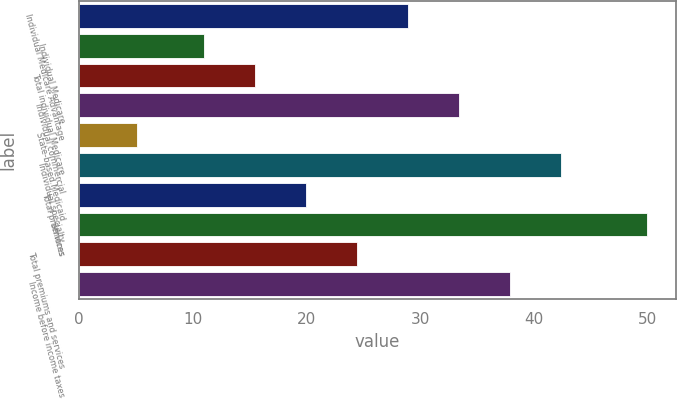Convert chart to OTSL. <chart><loc_0><loc_0><loc_500><loc_500><bar_chart><fcel>Individual Medicare Advantage<fcel>Individual Medicare<fcel>Total individual Medicare<fcel>Individual commercial<fcel>State-based Medicaid<fcel>Individual specialty<fcel>Total premiums<fcel>Services<fcel>Total premiums and services<fcel>Income before income taxes<nl><fcel>28.96<fcel>11<fcel>15.49<fcel>33.45<fcel>5.1<fcel>42.43<fcel>19.98<fcel>50<fcel>24.47<fcel>37.94<nl></chart> 